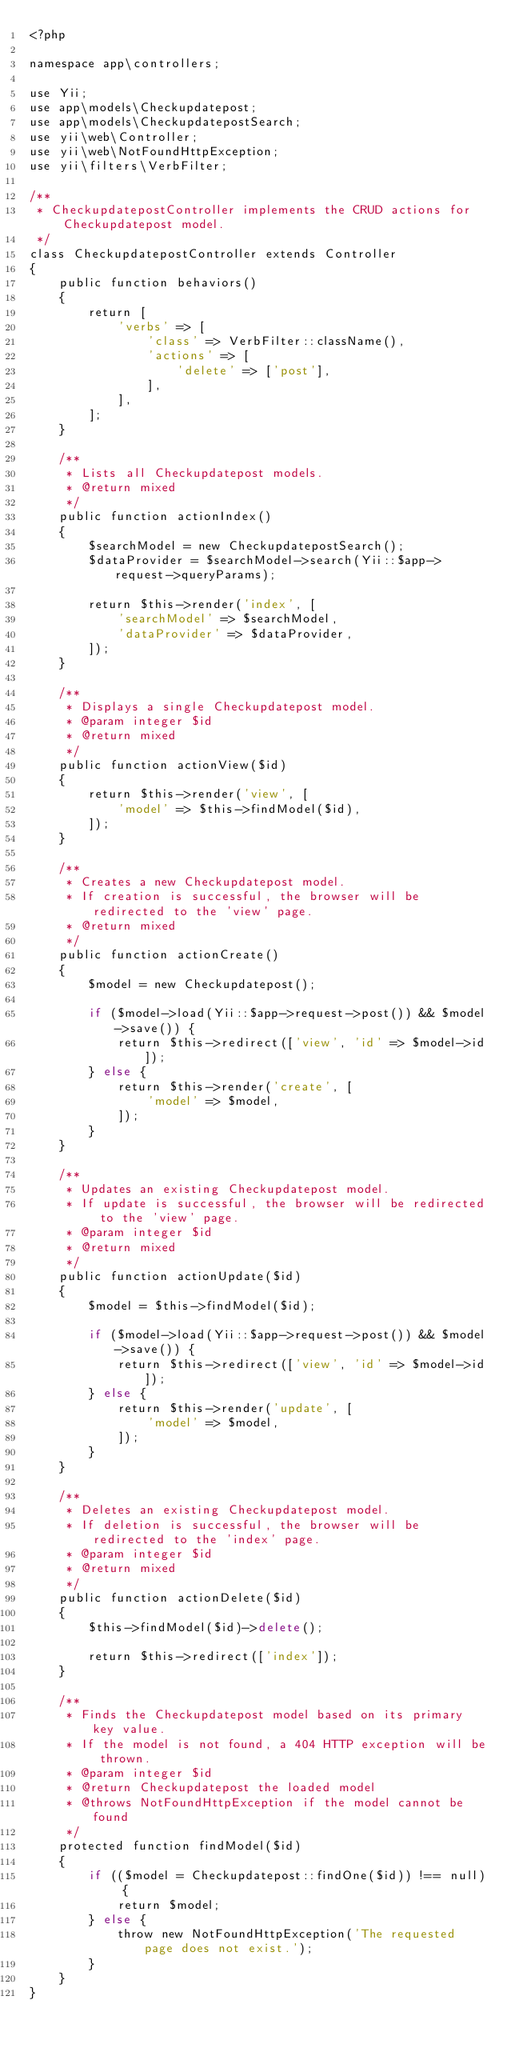<code> <loc_0><loc_0><loc_500><loc_500><_PHP_><?php

namespace app\controllers;

use Yii;
use app\models\Checkupdatepost;
use app\models\CheckupdatepostSearch;
use yii\web\Controller;
use yii\web\NotFoundHttpException;
use yii\filters\VerbFilter;

/**
 * CheckupdatepostController implements the CRUD actions for Checkupdatepost model.
 */
class CheckupdatepostController extends Controller
{
    public function behaviors()
    {
        return [
            'verbs' => [
                'class' => VerbFilter::className(),
                'actions' => [
                    'delete' => ['post'],
                ],
            ],
        ];
    }

    /**
     * Lists all Checkupdatepost models.
     * @return mixed
     */
    public function actionIndex()
    {
        $searchModel = new CheckupdatepostSearch();
        $dataProvider = $searchModel->search(Yii::$app->request->queryParams);

        return $this->render('index', [
            'searchModel' => $searchModel,
            'dataProvider' => $dataProvider,
        ]);
    }

    /**
     * Displays a single Checkupdatepost model.
     * @param integer $id
     * @return mixed
     */
    public function actionView($id)
    {
        return $this->render('view', [
            'model' => $this->findModel($id),
        ]);
    }

    /**
     * Creates a new Checkupdatepost model.
     * If creation is successful, the browser will be redirected to the 'view' page.
     * @return mixed
     */
    public function actionCreate()
    {
        $model = new Checkupdatepost();

        if ($model->load(Yii::$app->request->post()) && $model->save()) {
            return $this->redirect(['view', 'id' => $model->id]);
        } else {
            return $this->render('create', [
                'model' => $model,
            ]);
        }
    }

    /**
     * Updates an existing Checkupdatepost model.
     * If update is successful, the browser will be redirected to the 'view' page.
     * @param integer $id
     * @return mixed
     */
    public function actionUpdate($id)
    {
        $model = $this->findModel($id);

        if ($model->load(Yii::$app->request->post()) && $model->save()) {
            return $this->redirect(['view', 'id' => $model->id]);
        } else {
            return $this->render('update', [
                'model' => $model,
            ]);
        }
    }

    /**
     * Deletes an existing Checkupdatepost model.
     * If deletion is successful, the browser will be redirected to the 'index' page.
     * @param integer $id
     * @return mixed
     */
    public function actionDelete($id)
    {
        $this->findModel($id)->delete();

        return $this->redirect(['index']);
    }

    /**
     * Finds the Checkupdatepost model based on its primary key value.
     * If the model is not found, a 404 HTTP exception will be thrown.
     * @param integer $id
     * @return Checkupdatepost the loaded model
     * @throws NotFoundHttpException if the model cannot be found
     */
    protected function findModel($id)
    {
        if (($model = Checkupdatepost::findOne($id)) !== null) {
            return $model;
        } else {
            throw new NotFoundHttpException('The requested page does not exist.');
        }
    }
}
</code> 